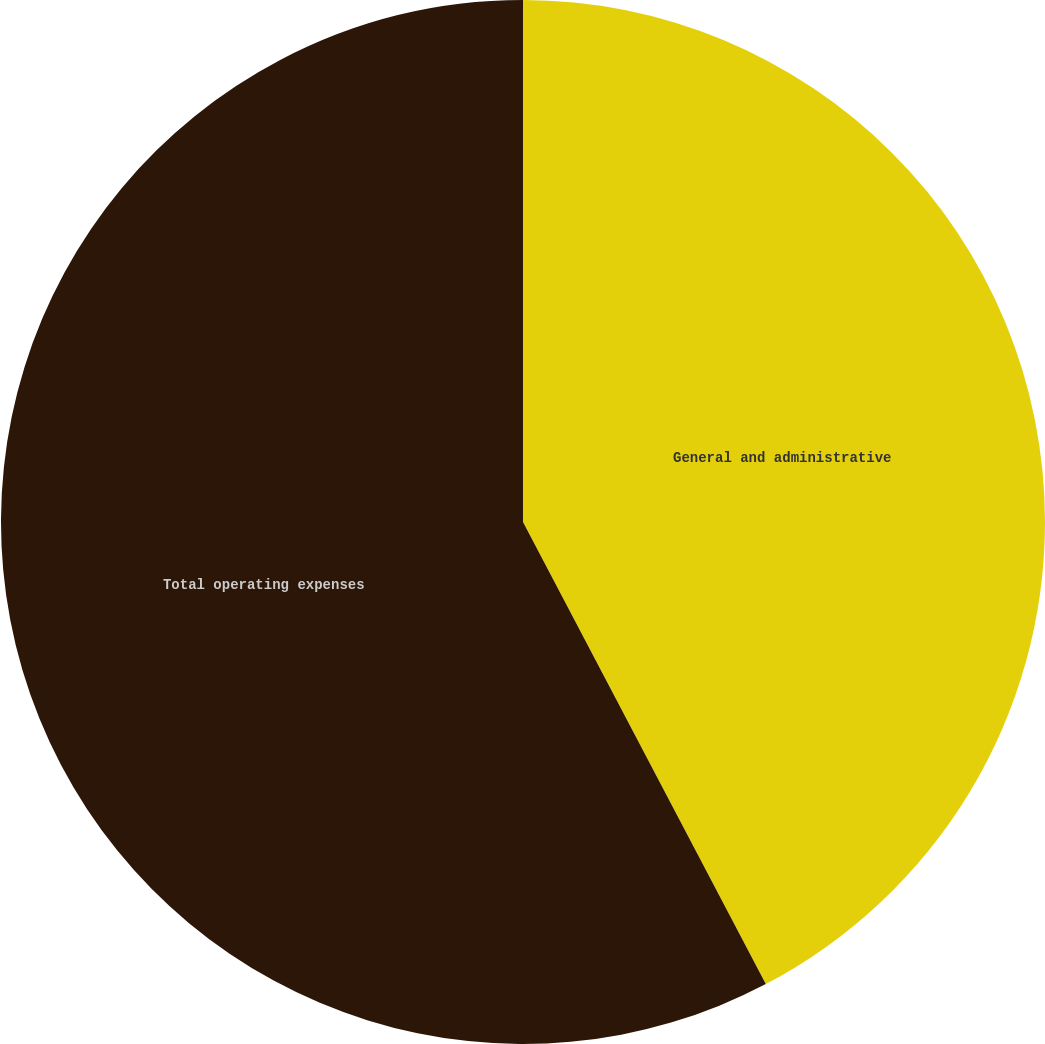Convert chart to OTSL. <chart><loc_0><loc_0><loc_500><loc_500><pie_chart><fcel>General and administrative<fcel>Total operating expenses<nl><fcel>42.3%<fcel>57.7%<nl></chart> 